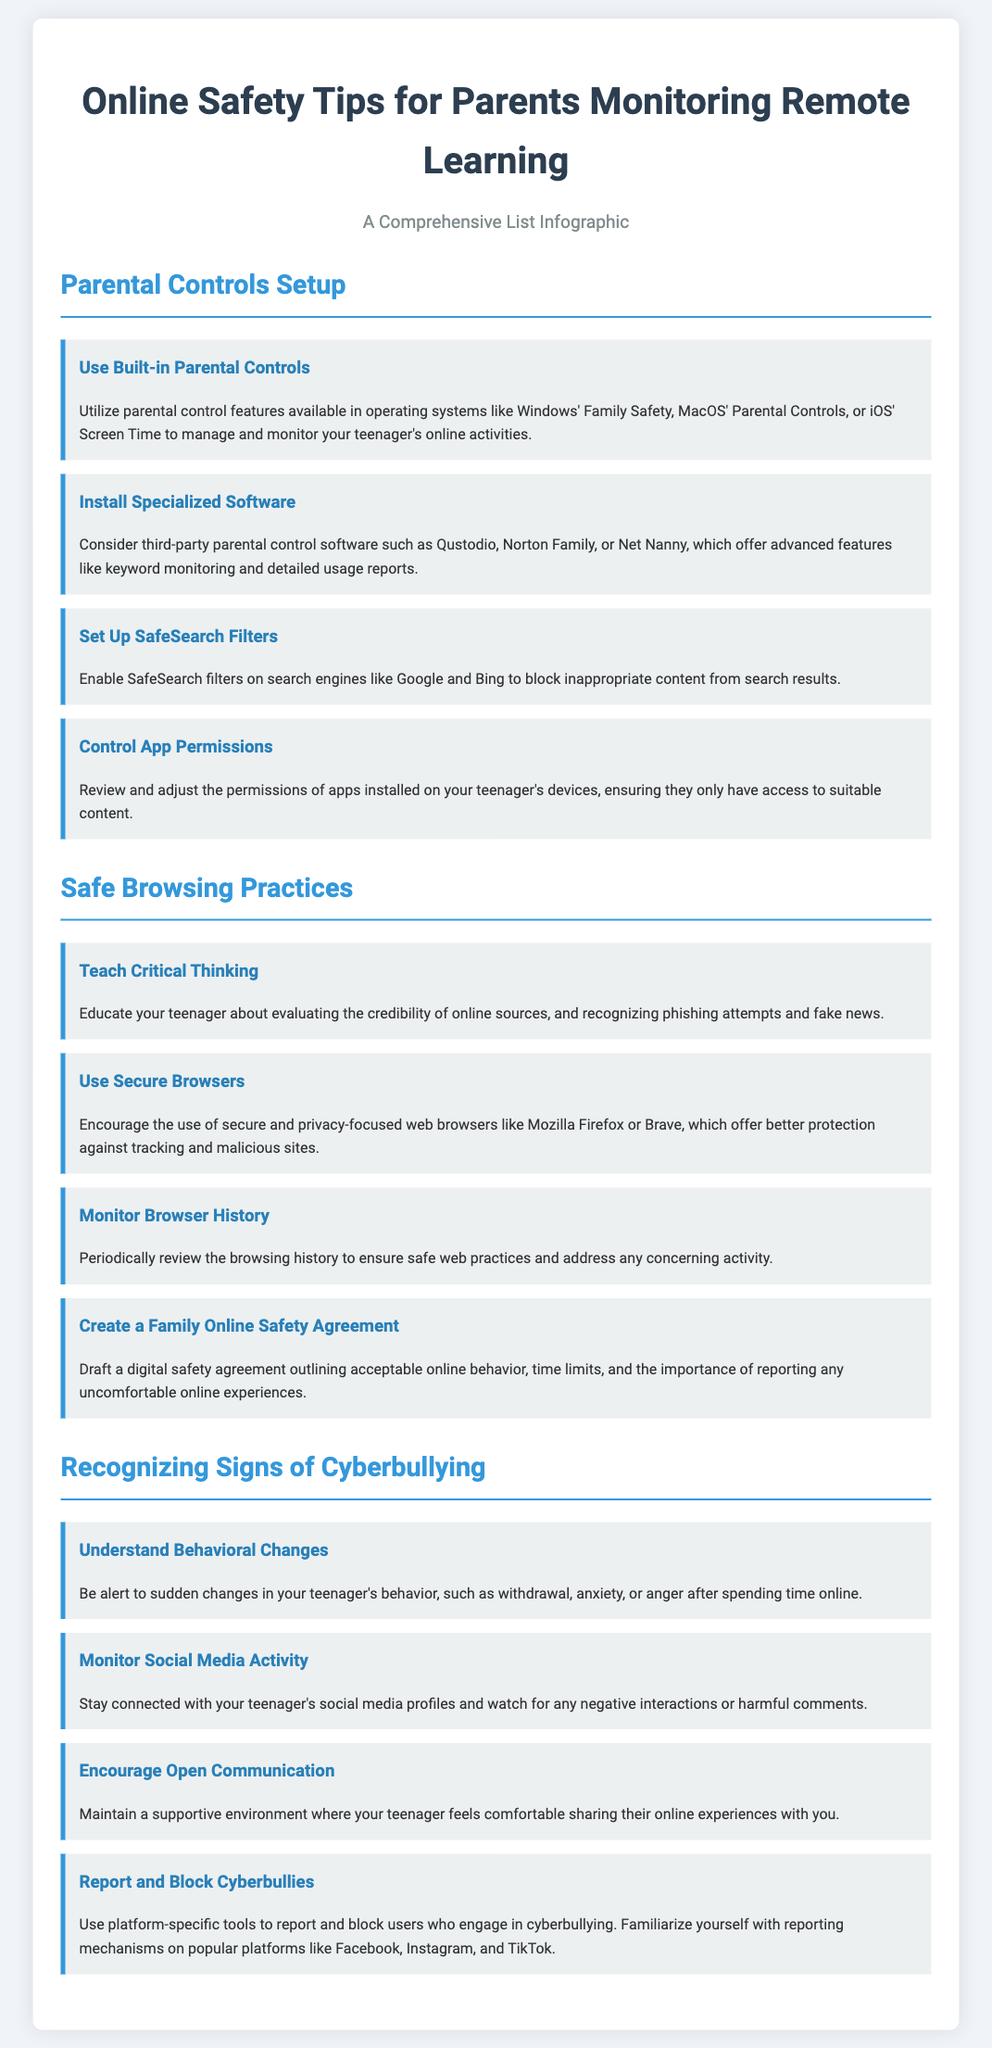What is the title of the document? The title of the document is presented at the top of the infographic, which outlines the main subject of the content.
Answer: Online Safety Tips for Parents Monitoring Remote Learning How many sections are in the document? The document is divided into three main sections: Parental Controls Setup, Safe Browsing Practices, and Recognizing Signs of Cyberbullying.
Answer: 3 Name one third-party parental control software mentioned. The document lists several third-party parental control software options, providing choices for parents to consider.
Answer: Qustodio What is one tip for recognizing signs of cyberbullying? One of the tips provided in the document specifically addresses behavioral changes in teenagers, which can indicate issues with cyberbullying.
Answer: Understand Behavioral Changes Which browser type is recommended for secure browsing? The document advises using secure browsers that are known for protecting users against tracking and malicious sites.
Answer: Secure and privacy-focused web browsers What should parents do to encourage honest communication about online experiences? The document suggests maintaining a supportive environment for teenagers, which can help them feel more comfortable discussing their online activities.
Answer: Encourage Open Communication What feature should be enabled on search engines? The document explains that there are specific filtering options available on search engines to help keep content appropriate.
Answer: SafeSearch filters What is an example of a behavior to watch for in teenagers? The document outlines certain emotional responses as potential signs of problems stemming from online interactions, indicating areas for parental attention.
Answer: Withdrawal 